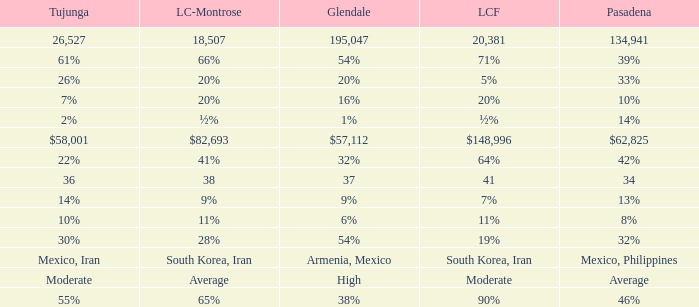When Tujunga is moderate, what is La Crescenta-Montrose? Average. 